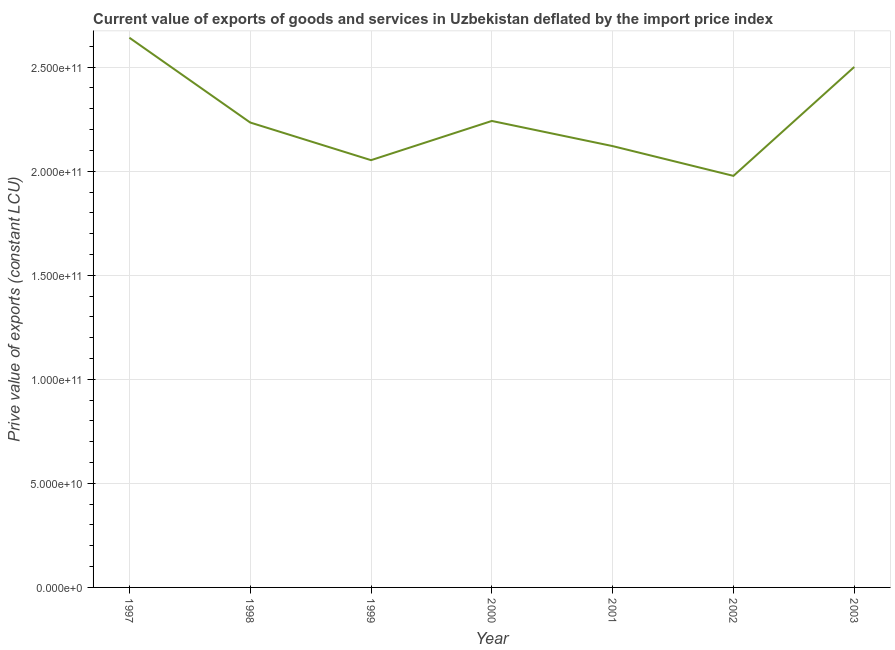What is the price value of exports in 2001?
Provide a succinct answer. 2.12e+11. Across all years, what is the maximum price value of exports?
Make the answer very short. 2.64e+11. Across all years, what is the minimum price value of exports?
Keep it short and to the point. 1.98e+11. What is the sum of the price value of exports?
Your response must be concise. 1.58e+12. What is the difference between the price value of exports in 2001 and 2002?
Your answer should be very brief. 1.43e+1. What is the average price value of exports per year?
Provide a short and direct response. 2.25e+11. What is the median price value of exports?
Make the answer very short. 2.23e+11. In how many years, is the price value of exports greater than 30000000000 LCU?
Offer a terse response. 7. Do a majority of the years between 2001 and 2002 (inclusive) have price value of exports greater than 20000000000 LCU?
Keep it short and to the point. Yes. What is the ratio of the price value of exports in 1999 to that in 2001?
Make the answer very short. 0.97. Is the price value of exports in 1998 less than that in 2003?
Keep it short and to the point. Yes. What is the difference between the highest and the second highest price value of exports?
Give a very brief answer. 1.40e+1. Is the sum of the price value of exports in 1998 and 2003 greater than the maximum price value of exports across all years?
Your answer should be compact. Yes. What is the difference between the highest and the lowest price value of exports?
Make the answer very short. 6.64e+1. Does the price value of exports monotonically increase over the years?
Provide a succinct answer. No. How many years are there in the graph?
Ensure brevity in your answer.  7. What is the difference between two consecutive major ticks on the Y-axis?
Your response must be concise. 5.00e+1. Are the values on the major ticks of Y-axis written in scientific E-notation?
Your response must be concise. Yes. Does the graph contain any zero values?
Your answer should be compact. No. What is the title of the graph?
Your answer should be very brief. Current value of exports of goods and services in Uzbekistan deflated by the import price index. What is the label or title of the Y-axis?
Ensure brevity in your answer.  Prive value of exports (constant LCU). What is the Prive value of exports (constant LCU) of 1997?
Your answer should be very brief. 2.64e+11. What is the Prive value of exports (constant LCU) of 1998?
Give a very brief answer. 2.23e+11. What is the Prive value of exports (constant LCU) of 1999?
Provide a short and direct response. 2.05e+11. What is the Prive value of exports (constant LCU) of 2000?
Ensure brevity in your answer.  2.24e+11. What is the Prive value of exports (constant LCU) of 2001?
Your answer should be compact. 2.12e+11. What is the Prive value of exports (constant LCU) in 2002?
Give a very brief answer. 1.98e+11. What is the Prive value of exports (constant LCU) of 2003?
Ensure brevity in your answer.  2.50e+11. What is the difference between the Prive value of exports (constant LCU) in 1997 and 1998?
Offer a terse response. 4.07e+1. What is the difference between the Prive value of exports (constant LCU) in 1997 and 1999?
Provide a succinct answer. 5.88e+1. What is the difference between the Prive value of exports (constant LCU) in 1997 and 2000?
Offer a terse response. 4.00e+1. What is the difference between the Prive value of exports (constant LCU) in 1997 and 2001?
Give a very brief answer. 5.21e+1. What is the difference between the Prive value of exports (constant LCU) in 1997 and 2002?
Make the answer very short. 6.64e+1. What is the difference between the Prive value of exports (constant LCU) in 1997 and 2003?
Give a very brief answer. 1.40e+1. What is the difference between the Prive value of exports (constant LCU) in 1998 and 1999?
Ensure brevity in your answer.  1.81e+1. What is the difference between the Prive value of exports (constant LCU) in 1998 and 2000?
Provide a succinct answer. -7.55e+08. What is the difference between the Prive value of exports (constant LCU) in 1998 and 2001?
Your response must be concise. 1.13e+1. What is the difference between the Prive value of exports (constant LCU) in 1998 and 2002?
Provide a succinct answer. 2.56e+1. What is the difference between the Prive value of exports (constant LCU) in 1998 and 2003?
Your answer should be compact. -2.67e+1. What is the difference between the Prive value of exports (constant LCU) in 1999 and 2000?
Ensure brevity in your answer.  -1.88e+1. What is the difference between the Prive value of exports (constant LCU) in 1999 and 2001?
Your answer should be very brief. -6.76e+09. What is the difference between the Prive value of exports (constant LCU) in 1999 and 2002?
Make the answer very short. 7.55e+09. What is the difference between the Prive value of exports (constant LCU) in 1999 and 2003?
Make the answer very short. -4.48e+1. What is the difference between the Prive value of exports (constant LCU) in 2000 and 2001?
Ensure brevity in your answer.  1.21e+1. What is the difference between the Prive value of exports (constant LCU) in 2000 and 2002?
Ensure brevity in your answer.  2.64e+1. What is the difference between the Prive value of exports (constant LCU) in 2000 and 2003?
Ensure brevity in your answer.  -2.59e+1. What is the difference between the Prive value of exports (constant LCU) in 2001 and 2002?
Your response must be concise. 1.43e+1. What is the difference between the Prive value of exports (constant LCU) in 2001 and 2003?
Your response must be concise. -3.80e+1. What is the difference between the Prive value of exports (constant LCU) in 2002 and 2003?
Offer a terse response. -5.23e+1. What is the ratio of the Prive value of exports (constant LCU) in 1997 to that in 1998?
Give a very brief answer. 1.18. What is the ratio of the Prive value of exports (constant LCU) in 1997 to that in 1999?
Give a very brief answer. 1.29. What is the ratio of the Prive value of exports (constant LCU) in 1997 to that in 2000?
Give a very brief answer. 1.18. What is the ratio of the Prive value of exports (constant LCU) in 1997 to that in 2001?
Your answer should be compact. 1.25. What is the ratio of the Prive value of exports (constant LCU) in 1997 to that in 2002?
Give a very brief answer. 1.34. What is the ratio of the Prive value of exports (constant LCU) in 1997 to that in 2003?
Offer a very short reply. 1.06. What is the ratio of the Prive value of exports (constant LCU) in 1998 to that in 1999?
Make the answer very short. 1.09. What is the ratio of the Prive value of exports (constant LCU) in 1998 to that in 2000?
Ensure brevity in your answer.  1. What is the ratio of the Prive value of exports (constant LCU) in 1998 to that in 2001?
Make the answer very short. 1.05. What is the ratio of the Prive value of exports (constant LCU) in 1998 to that in 2002?
Offer a very short reply. 1.13. What is the ratio of the Prive value of exports (constant LCU) in 1998 to that in 2003?
Your answer should be compact. 0.89. What is the ratio of the Prive value of exports (constant LCU) in 1999 to that in 2000?
Keep it short and to the point. 0.92. What is the ratio of the Prive value of exports (constant LCU) in 1999 to that in 2001?
Your answer should be compact. 0.97. What is the ratio of the Prive value of exports (constant LCU) in 1999 to that in 2002?
Your answer should be compact. 1.04. What is the ratio of the Prive value of exports (constant LCU) in 1999 to that in 2003?
Provide a succinct answer. 0.82. What is the ratio of the Prive value of exports (constant LCU) in 2000 to that in 2001?
Provide a short and direct response. 1.06. What is the ratio of the Prive value of exports (constant LCU) in 2000 to that in 2002?
Keep it short and to the point. 1.13. What is the ratio of the Prive value of exports (constant LCU) in 2000 to that in 2003?
Your answer should be compact. 0.9. What is the ratio of the Prive value of exports (constant LCU) in 2001 to that in 2002?
Keep it short and to the point. 1.07. What is the ratio of the Prive value of exports (constant LCU) in 2001 to that in 2003?
Offer a very short reply. 0.85. What is the ratio of the Prive value of exports (constant LCU) in 2002 to that in 2003?
Offer a terse response. 0.79. 